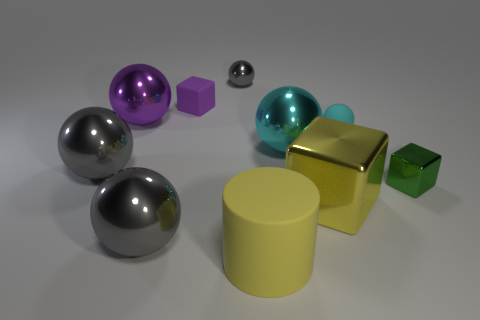Subtract all gray spheres. How many were subtracted if there are1gray spheres left? 2 Subtract all large yellow metal blocks. How many blocks are left? 2 Subtract all gray blocks. How many cyan balls are left? 2 Subtract all gray balls. How many balls are left? 3 Subtract all cubes. How many objects are left? 7 Subtract 3 balls. How many balls are left? 3 Add 8 big cyan objects. How many big cyan objects exist? 9 Subtract 0 blue balls. How many objects are left? 10 Subtract all green cylinders. Subtract all blue cubes. How many cylinders are left? 1 Subtract all rubber spheres. Subtract all cyan matte objects. How many objects are left? 8 